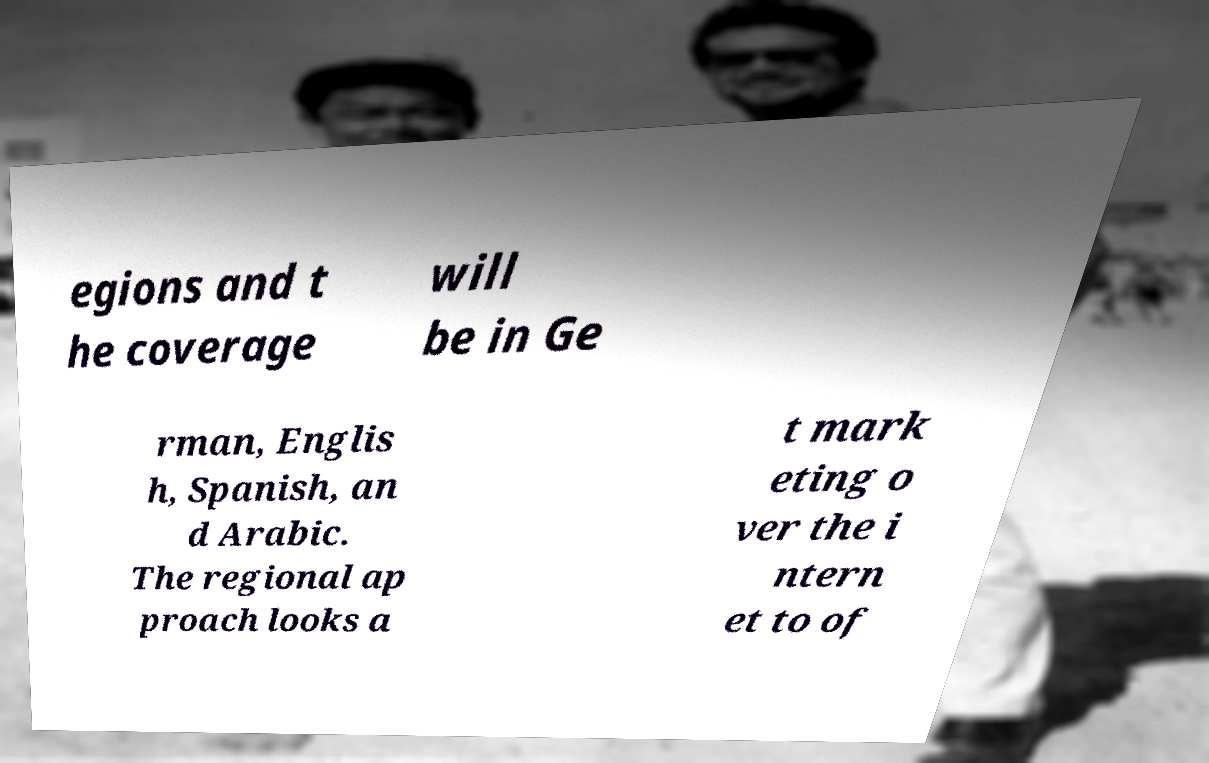Could you assist in decoding the text presented in this image and type it out clearly? egions and t he coverage will be in Ge rman, Englis h, Spanish, an d Arabic. The regional ap proach looks a t mark eting o ver the i ntern et to of 